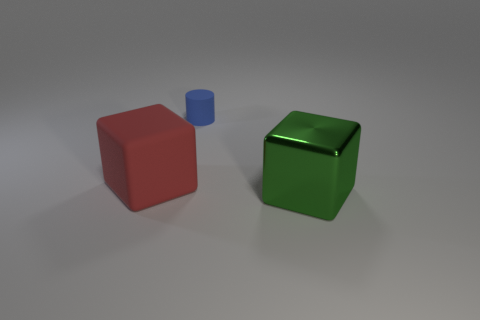Does the object that is to the right of the blue object have the same shape as the rubber thing in front of the tiny blue cylinder?
Provide a succinct answer. Yes. There is a small cylinder that is made of the same material as the red cube; what color is it?
Your answer should be compact. Blue. Is the size of the thing that is in front of the red rubber block the same as the rubber thing behind the big red matte cube?
Provide a succinct answer. No. What shape is the object that is both in front of the tiny blue matte thing and on the right side of the red rubber cube?
Keep it short and to the point. Cube. Are there any large red blocks that have the same material as the small object?
Provide a short and direct response. Yes. Is the material of the block left of the big shiny thing the same as the big block that is on the right side of the large red rubber object?
Keep it short and to the point. No. Are there more tiny blue objects than tiny purple rubber balls?
Provide a succinct answer. Yes. What is the color of the tiny matte cylinder that is behind the large block on the left side of the cube that is on the right side of the big rubber block?
Your response must be concise. Blue. Is the color of the big block in front of the red object the same as the rubber thing right of the red block?
Make the answer very short. No. What number of red matte things are left of the large block behind the large green metallic object?
Offer a terse response. 0. 